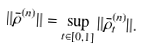Convert formula to latex. <formula><loc_0><loc_0><loc_500><loc_500>\| \bar { \rho } ^ { ( n ) } \| = \sup _ { t \in [ 0 , 1 ] } \| \bar { \rho } _ { t } ^ { ( n ) } \| .</formula> 